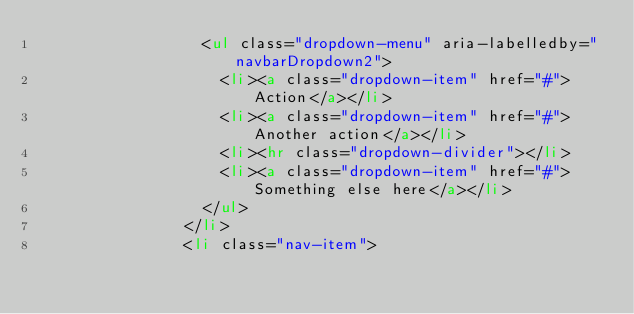Convert code to text. <code><loc_0><loc_0><loc_500><loc_500><_HTML_>                  <ul class="dropdown-menu" aria-labelledby="navbarDropdown2">
                    <li><a class="dropdown-item" href="#">Action</a></li>
                    <li><a class="dropdown-item" href="#">Another action</a></li>
                    <li><hr class="dropdown-divider"></li>
                    <li><a class="dropdown-item" href="#">Something else here</a></li>
                  </ul>
                </li>
                <li class="nav-item"></code> 